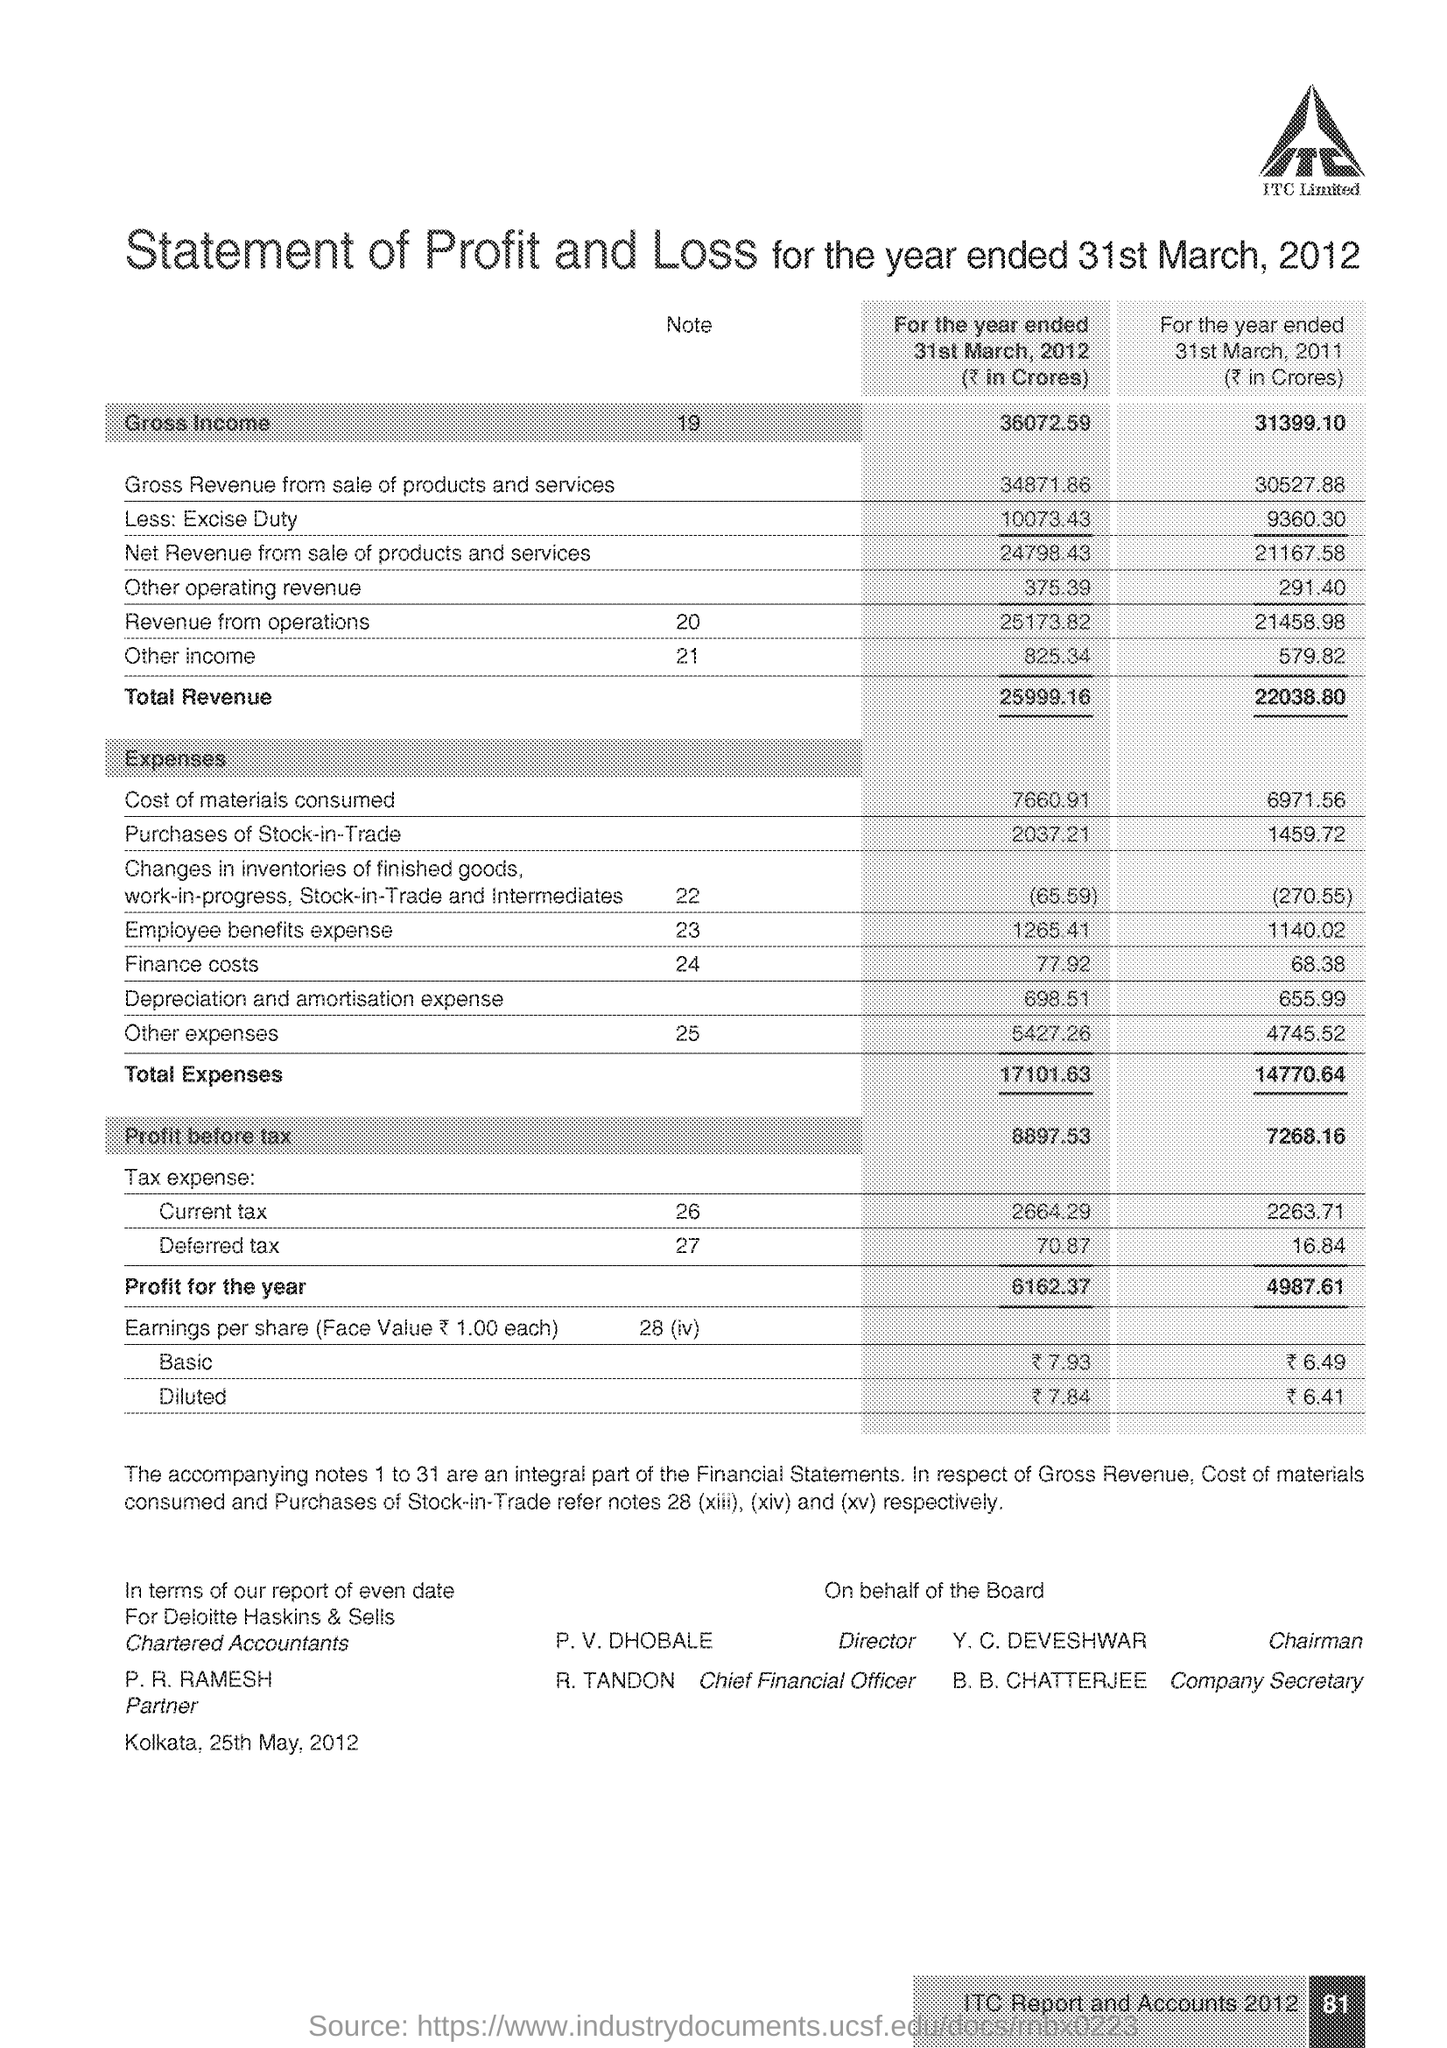List a handful of essential elements in this visual. The total expenses for the end of 31st March 2012 were 17,101.63. The total revenue at the end of 31st March 2011 was 22038.80. The total gross income for the end of March 2012 was 36,072.59. The total expenses at the end of 31st March 2011 were 14770.64... The total amount of gross income at the end of March 31, 2011 was 31,399.10. 